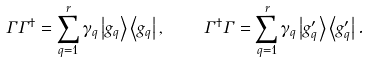Convert formula to latex. <formula><loc_0><loc_0><loc_500><loc_500>\Gamma \Gamma ^ { \dag } = \sum _ { q = 1 } ^ { r } \gamma _ { q } \left | g _ { q } \right \rangle \left \langle g _ { q } \right | , \quad \Gamma ^ { \dag } \Gamma = \sum _ { q = 1 } ^ { r } \gamma _ { q } \left | g _ { q } ^ { \prime } \right \rangle \left \langle g _ { q } ^ { \prime } \right | .</formula> 